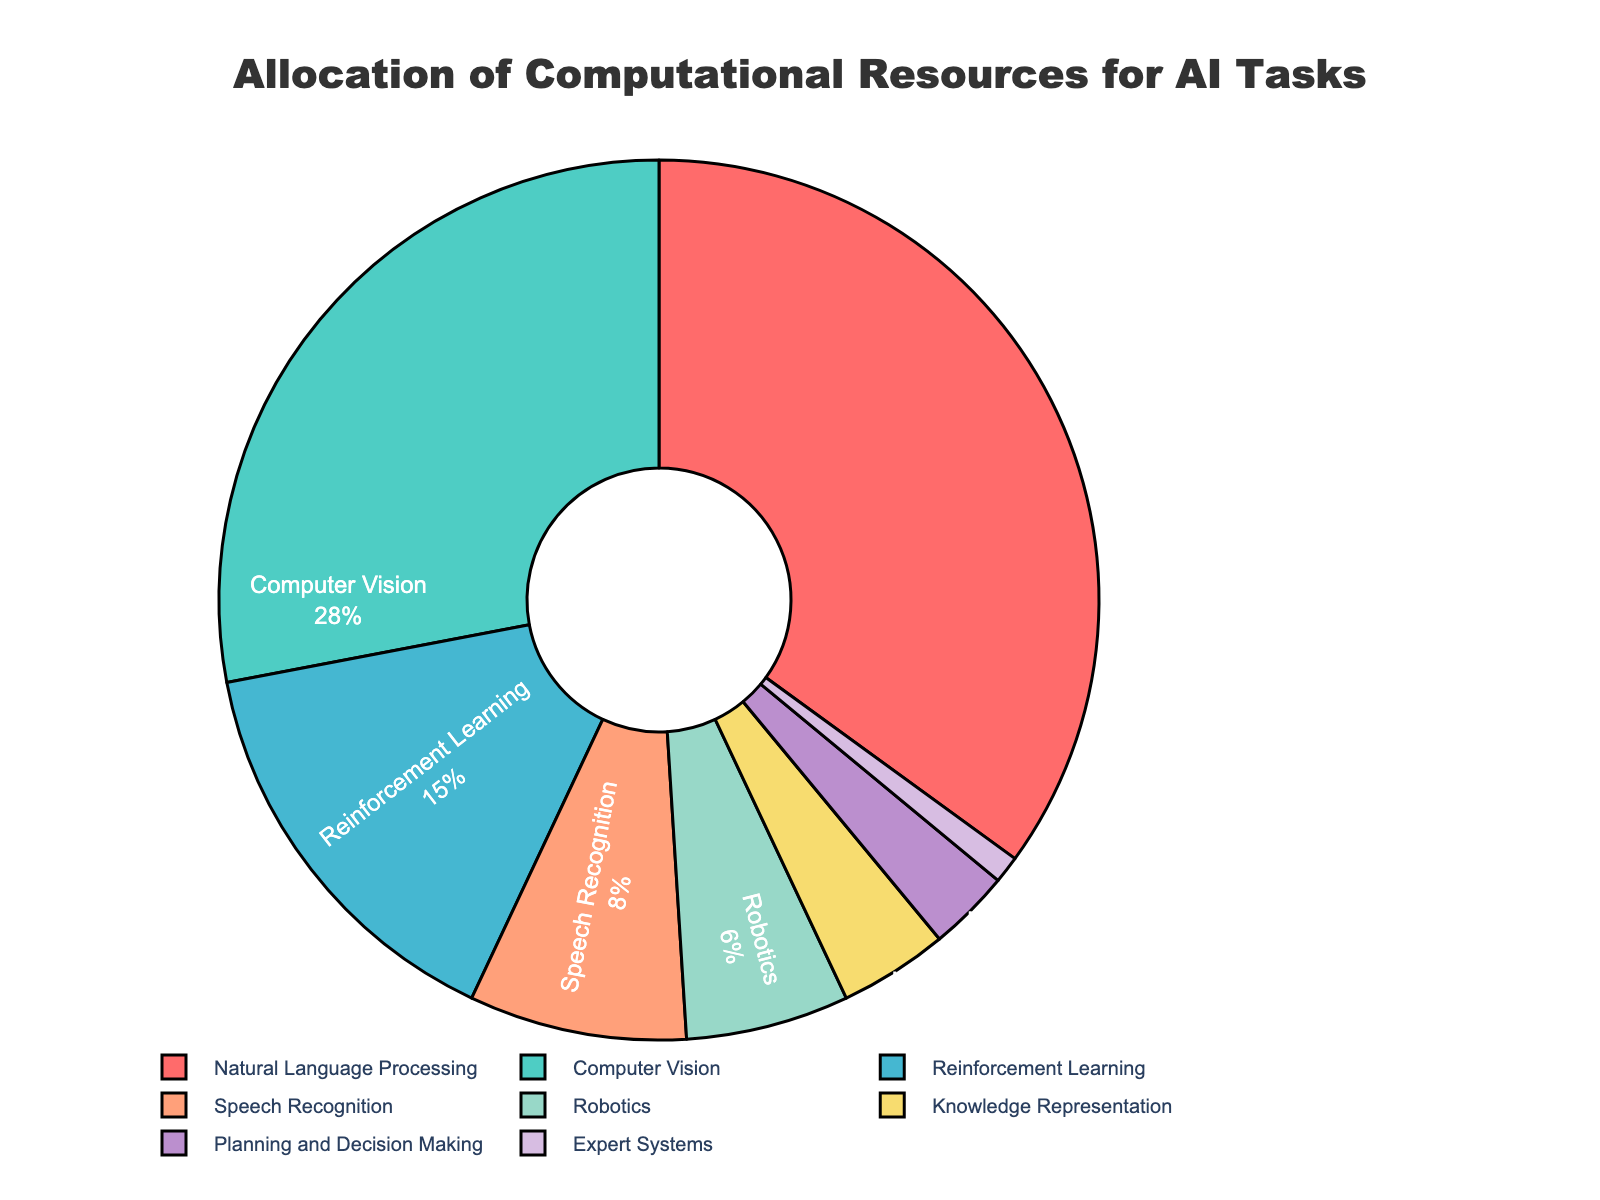Which AI task receives the largest allocation of computational resources? According to the pie chart, Natural Language Processing has the largest slice indicating it receives the highest allocation.
Answer: Natural Language Processing What is the total percentage allocated to Computer Vision and Reinforcement Learning combined? From the pie chart, Computer Vision has 28% and Reinforcement Learning has 15%. Adding these together, 28 + 15 = 43.
Answer: 43% How much more computational resource is allocated to Natural Language Processing compared to Planning and Decision Making? The pie chart shows Natural Language Processing with 35% and Planning and Decision Making with 3%. The difference is 35 - 3 = 32.
Answer: 32% Which two AI tasks have the smallest allocation of computational resources, and what is their combined percentage? Referencing the pie chart, the two smallest slices represent Expert Systems (1%) and Planning and Decision Making (3%). Their combined percentage is 1 + 3 = 4.
Answer: Expert Systems and Planning and Decision Making, 4% Compare the allocation percentages between Computer Vision and Robotics. The pie chart indicates Computer Vision at 28% and Robotics at 6%. Therefore, Computer Vision gets more computational resources compared to Robotics.
Answer: Computer Vision What is the percentage difference between the resources allocated to Speech Recognition and Knowledge Representation? The pie chart shows Speech Recognition with 8% and Knowledge Representation with 4%. The difference is 8 - 4 = 4.
Answer: 4% If we combine the resources for Speech Recognition, Robotics, Knowledge Representation, Planning and Decision Making, and Expert Systems, what is the total percentage allocation? Summing their percentages, Speech Recognition (8%) + Robotics (6%) + Knowledge Representation (4%) + Planning and Decision Making (3%) + Expert Systems (1%) equals 22%.
Answer: 22% What proportion of the total computational resources is allocated to tasks other than Natural Language Processing and Computer Vision? The combined percentage for Natural Language Processing and Computer Vision is 35% + 28% = 63%. The resources allocated to other tasks is 100 - 63 = 37.
Answer: 37% How does the allocation for Computer Vision compare visually to that of Speech Recognition based on the pie chart? By visually comparing the slices, Computer Vision (28%) has a significantly larger slice than Speech Recognition (8%).
Answer: Computer Vision is larger Is the percentage allocated to Natural Language Processing greater than the total percentage allocated to Reinforcement Learning, Speech Recognition, and Robotics combined? Reinforcement Learning (15%) + Speech Recognition (8%) + Robotics (6%) totals 29%. Natural Language Processing alone is 35%, which is greater than 29%.
Answer: Yes 